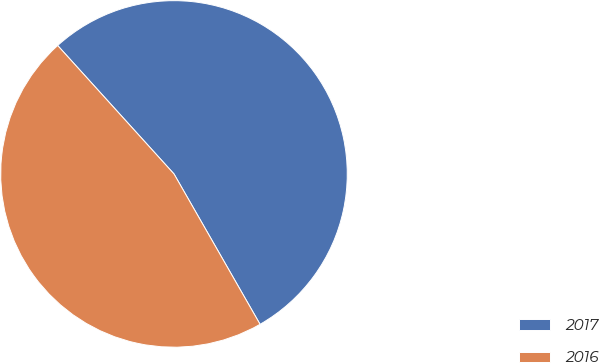<chart> <loc_0><loc_0><loc_500><loc_500><pie_chart><fcel>2017<fcel>2016<nl><fcel>53.44%<fcel>46.56%<nl></chart> 